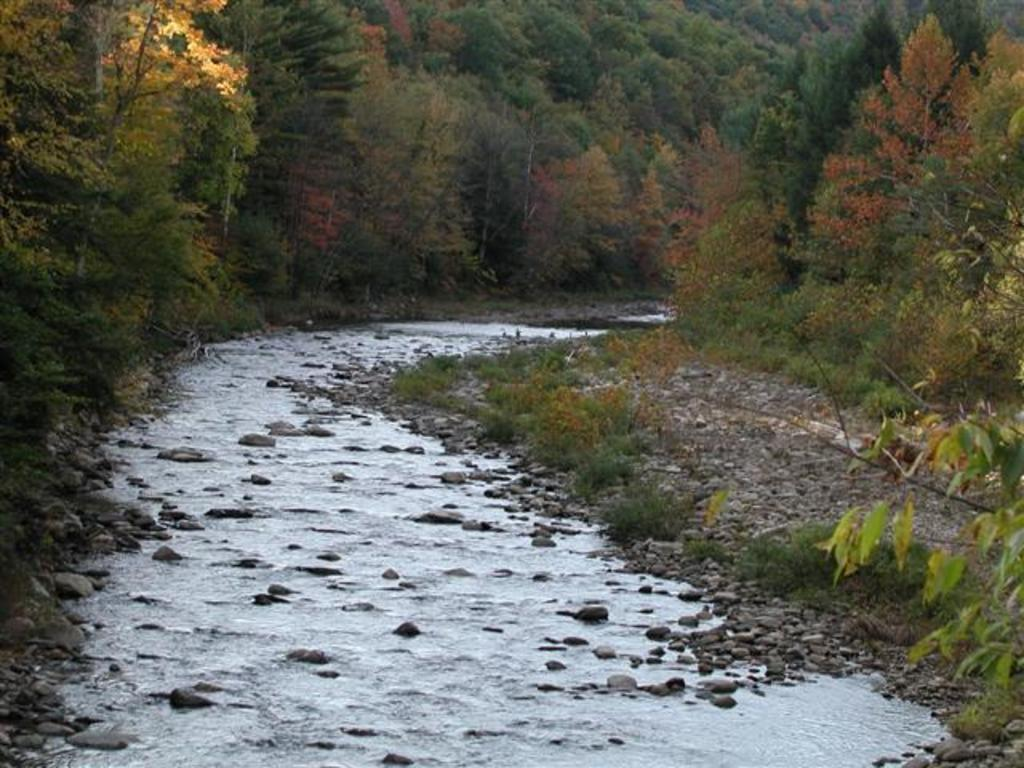What type of natural feature is present in the image? There is a river in the image. What other natural elements can be seen in the image? There are plants, stones, and trees in the image. What type of frame surrounds the image? There is no frame present in the image; it is a photograph or illustration of a natural scene. What type of holiday is being celebrated in the image? There is no indication of a holiday being celebrated in the image, as it features a natural scene with a river, plants, stones, and trees. 